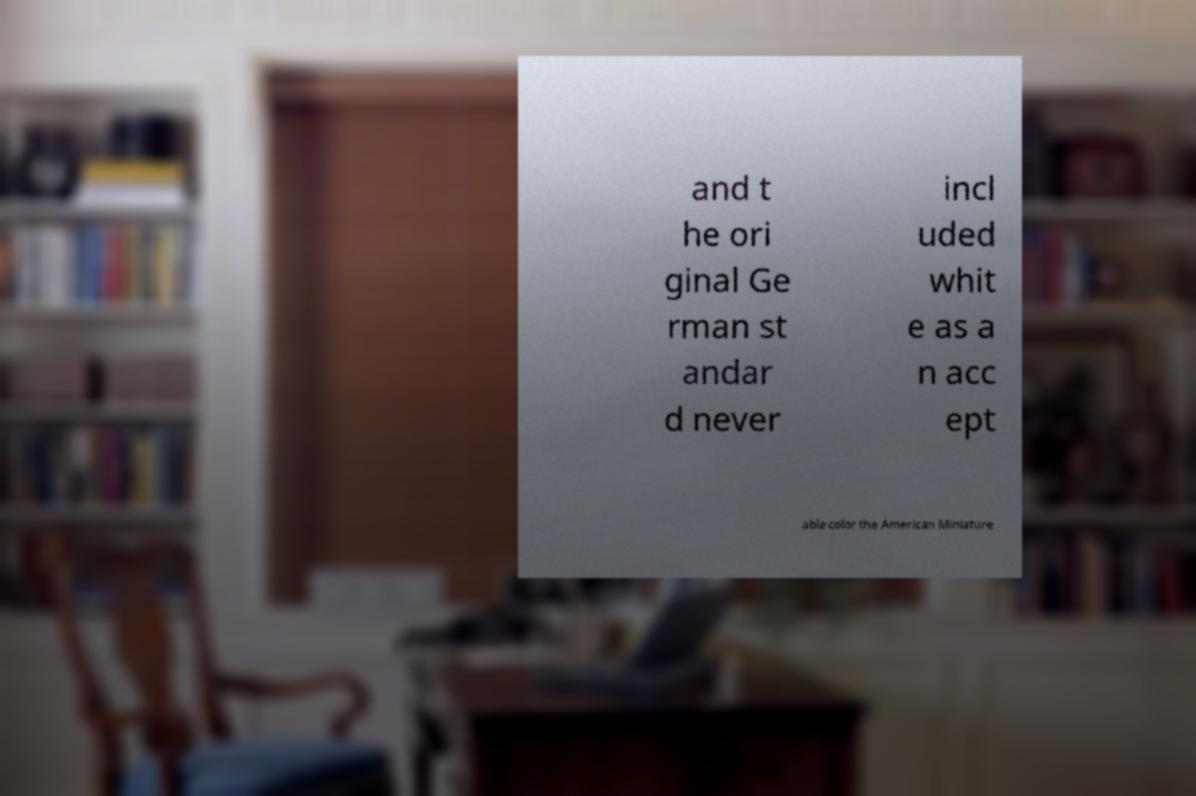I need the written content from this picture converted into text. Can you do that? and t he ori ginal Ge rman st andar d never incl uded whit e as a n acc ept able color the American Miniature 